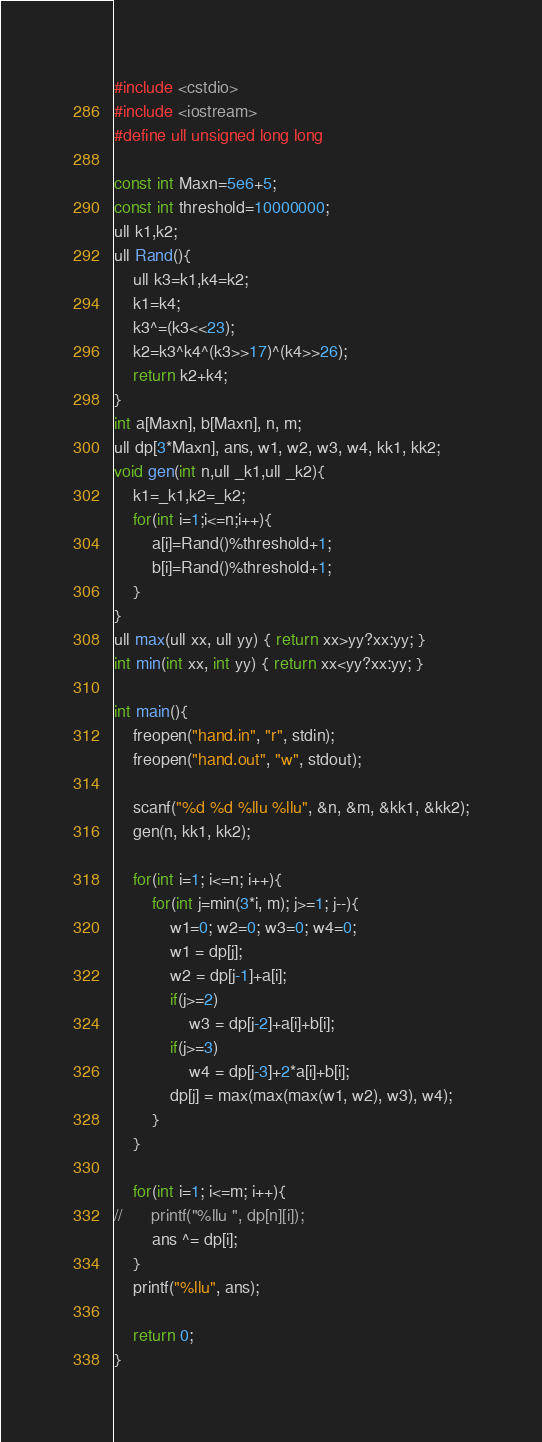Convert code to text. <code><loc_0><loc_0><loc_500><loc_500><_C++_>#include <cstdio>
#include <iostream>
#define ull unsigned long long

const int Maxn=5e6+5;
const int threshold=10000000;
ull k1,k2;
ull Rand(){
	ull k3=k1,k4=k2;
	k1=k4;
	k3^=(k3<<23);
	k2=k3^k4^(k3>>17)^(k4>>26);
	return k2+k4;
}
int a[Maxn], b[Maxn], n, m;
ull dp[3*Maxn], ans, w1, w2, w3, w4, kk1, kk2;
void gen(int n,ull _k1,ull _k2){
	k1=_k1,k2=_k2;
	for(int i=1;i<=n;i++){
		a[i]=Rand()%threshold+1;
		b[i]=Rand()%threshold+1;
	}
}
ull max(ull xx, ull yy) { return xx>yy?xx:yy; }
int min(int xx, int yy) { return xx<yy?xx:yy; }

int main(){
	freopen("hand.in", "r", stdin);
	freopen("hand.out", "w", stdout);

	scanf("%d %d %llu %llu", &n, &m, &kk1, &kk2);
	gen(n, kk1, kk2);

	for(int i=1; i<=n; i++){
		for(int j=min(3*i, m); j>=1; j--){
			w1=0; w2=0; w3=0; w4=0;
			w1 = dp[j];
			w2 = dp[j-1]+a[i];
			if(j>=2)
				w3 = dp[j-2]+a[i]+b[i];
			if(j>=3)
				w4 = dp[j-3]+2*a[i]+b[i];
			dp[j] = max(max(max(w1, w2), w3), w4);
		}
	}

	for(int i=1; i<=m; i++){
//		printf("%llu ", dp[n][i]);
		ans ^= dp[i];
	}
	printf("%llu", ans);

	return 0;
}
</code> 